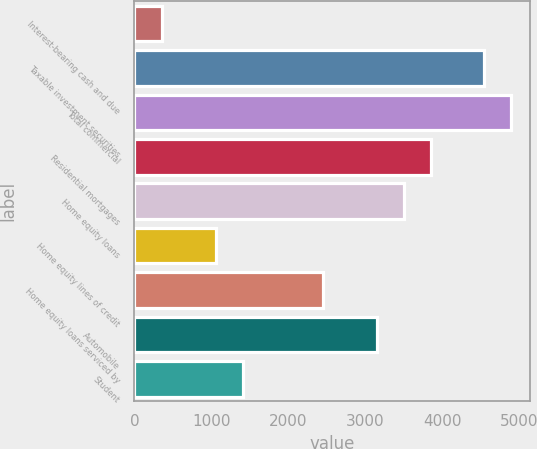Convert chart. <chart><loc_0><loc_0><loc_500><loc_500><bar_chart><fcel>Interest-bearing cash and due<fcel>Taxable investment securities<fcel>Total commercial<fcel>Residential mortgages<fcel>Home equity loans<fcel>Home equity lines of credit<fcel>Home equity loans serviced by<fcel>Automobile<fcel>Student<nl><fcel>357.3<fcel>4548.9<fcel>4898.2<fcel>3850.3<fcel>3501<fcel>1055.9<fcel>2453.1<fcel>3151.7<fcel>1405.2<nl></chart> 